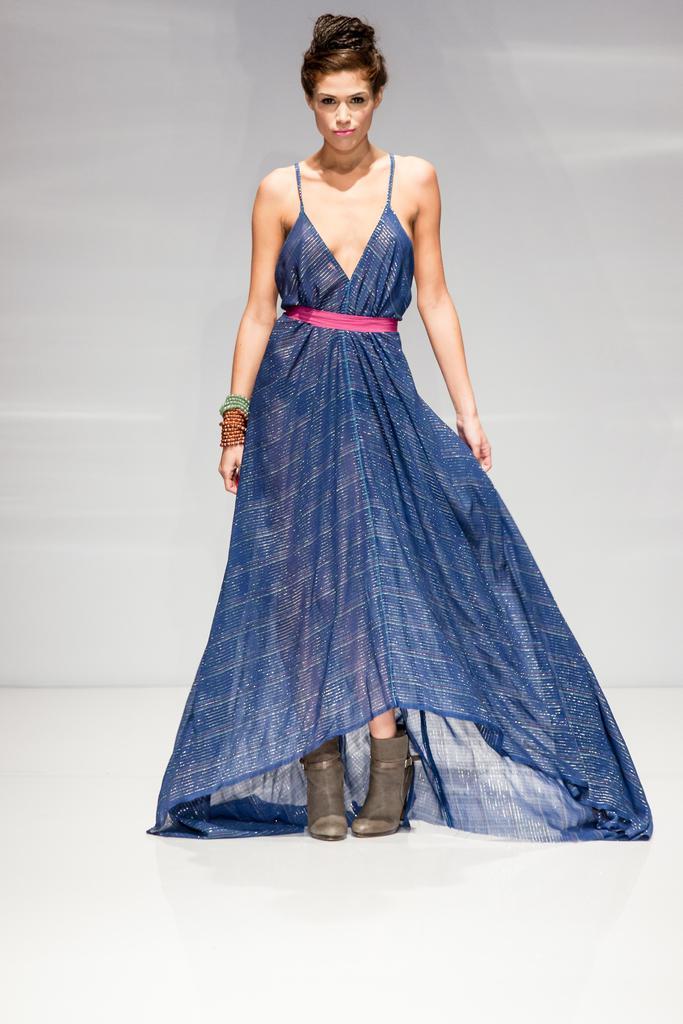Could you give a brief overview of what you see in this image? In this picture we can see a woman standing on the floor. 